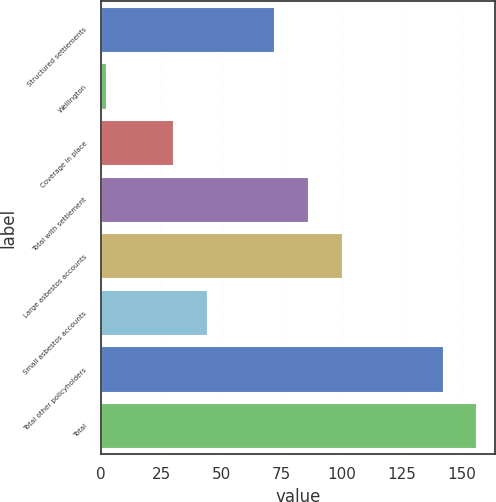Convert chart. <chart><loc_0><loc_0><loc_500><loc_500><bar_chart><fcel>Structured settlements<fcel>Wellington<fcel>Coverage in place<fcel>Total with settlement<fcel>Large asbestos accounts<fcel>Small asbestos accounts<fcel>Total other policyholders<fcel>Total<nl><fcel>72<fcel>2<fcel>30<fcel>86<fcel>100<fcel>44<fcel>142<fcel>156<nl></chart> 